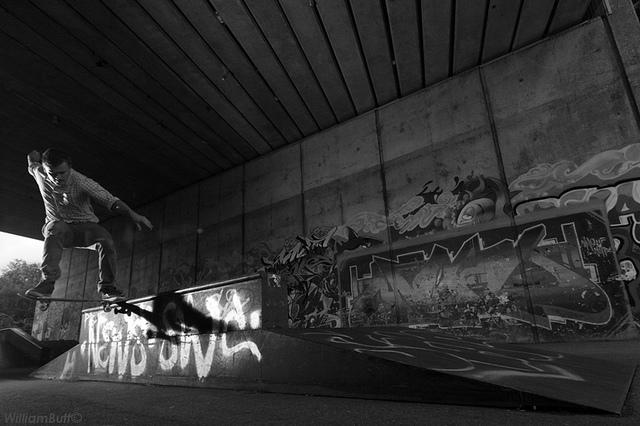How many skateboards are in this scene?
Be succinct. 1. Is the skateboard on a ramp?
Short answer required. No. Is there a body of water in the image?
Keep it brief. No. What is on the walls of the ramp?
Write a very short answer. Graffiti. How many slats do you see?
Concise answer only. 0. What color is the skaters hat?
Concise answer only. No hat. 